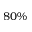<formula> <loc_0><loc_0><loc_500><loc_500>8 0 \%</formula> 